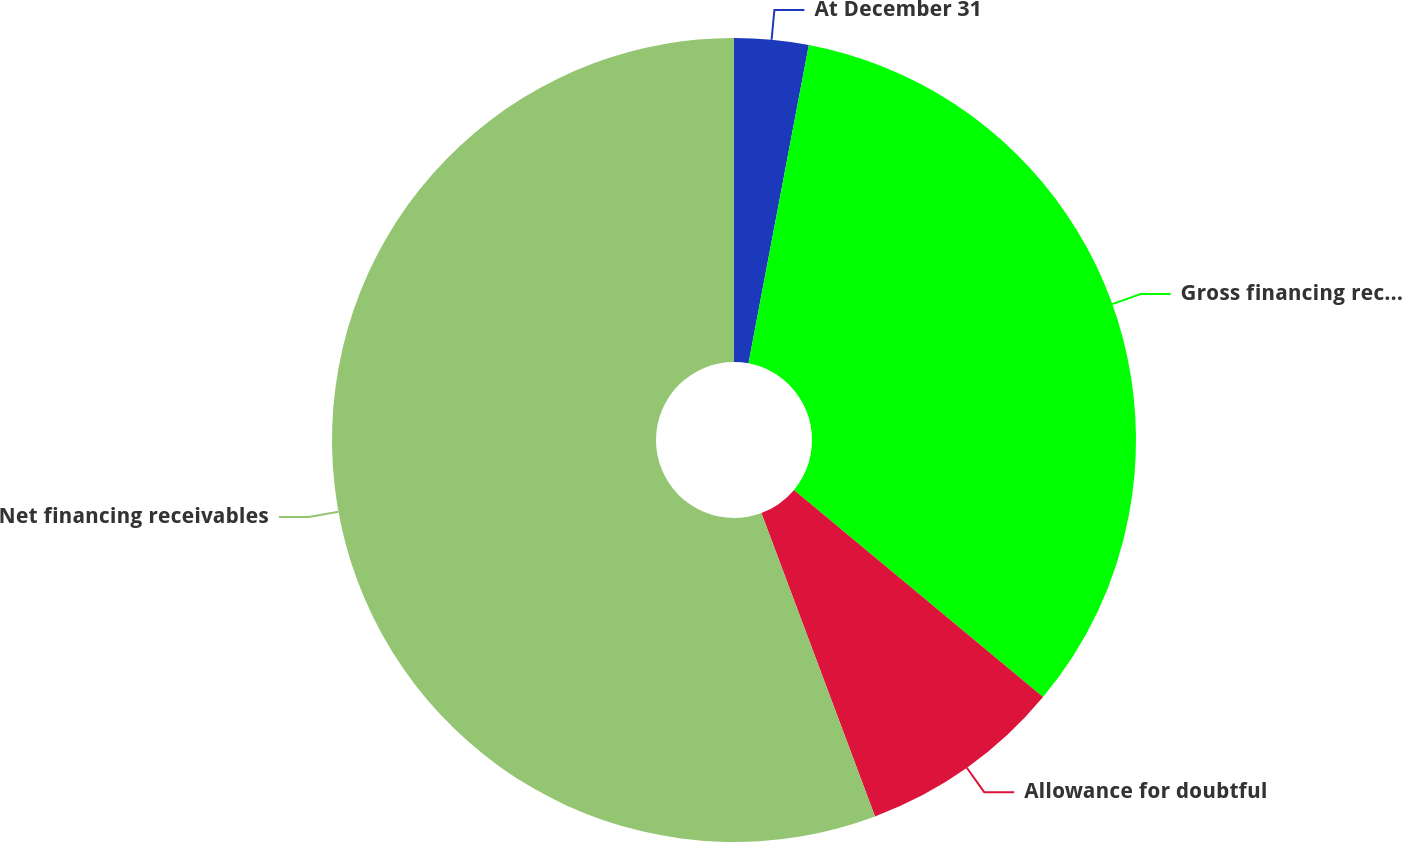Convert chart. <chart><loc_0><loc_0><loc_500><loc_500><pie_chart><fcel>At December 31<fcel>Gross financing receivables<fcel>Allowance for doubtful<fcel>Net financing receivables<nl><fcel>2.98%<fcel>33.06%<fcel>8.25%<fcel>55.7%<nl></chart> 